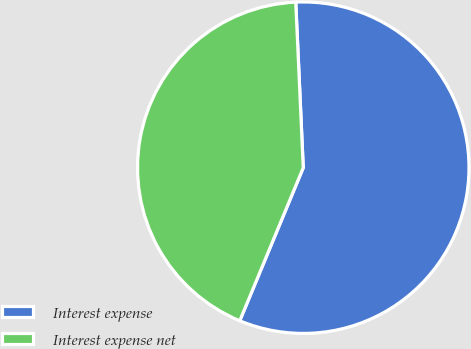Convert chart to OTSL. <chart><loc_0><loc_0><loc_500><loc_500><pie_chart><fcel>Interest expense<fcel>Interest expense net<nl><fcel>56.98%<fcel>43.02%<nl></chart> 